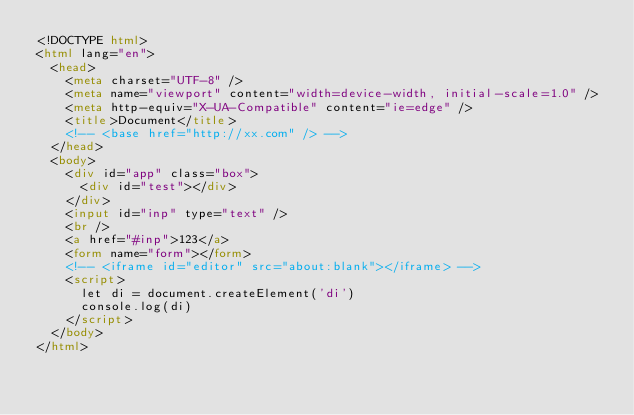Convert code to text. <code><loc_0><loc_0><loc_500><loc_500><_HTML_><!DOCTYPE html>
<html lang="en">
  <head>
    <meta charset="UTF-8" />
    <meta name="viewport" content="width=device-width, initial-scale=1.0" />
    <meta http-equiv="X-UA-Compatible" content="ie=edge" />
    <title>Document</title>
    <!-- <base href="http://xx.com" /> -->
  </head>
  <body>
    <div id="app" class="box">
      <div id="test"></div>
    </div>
    <input id="inp" type="text" />
    <br />
    <a href="#inp">123</a>
    <form name="form"></form>
    <!-- <iframe id="editor" src="about:blank"></iframe> -->
    <script>
      let di = document.createElement('di')
      console.log(di)
    </script>
  </body>
</html>
</code> 